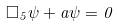<formula> <loc_0><loc_0><loc_500><loc_500>\Box _ { 5 } \psi + a \psi = 0</formula> 